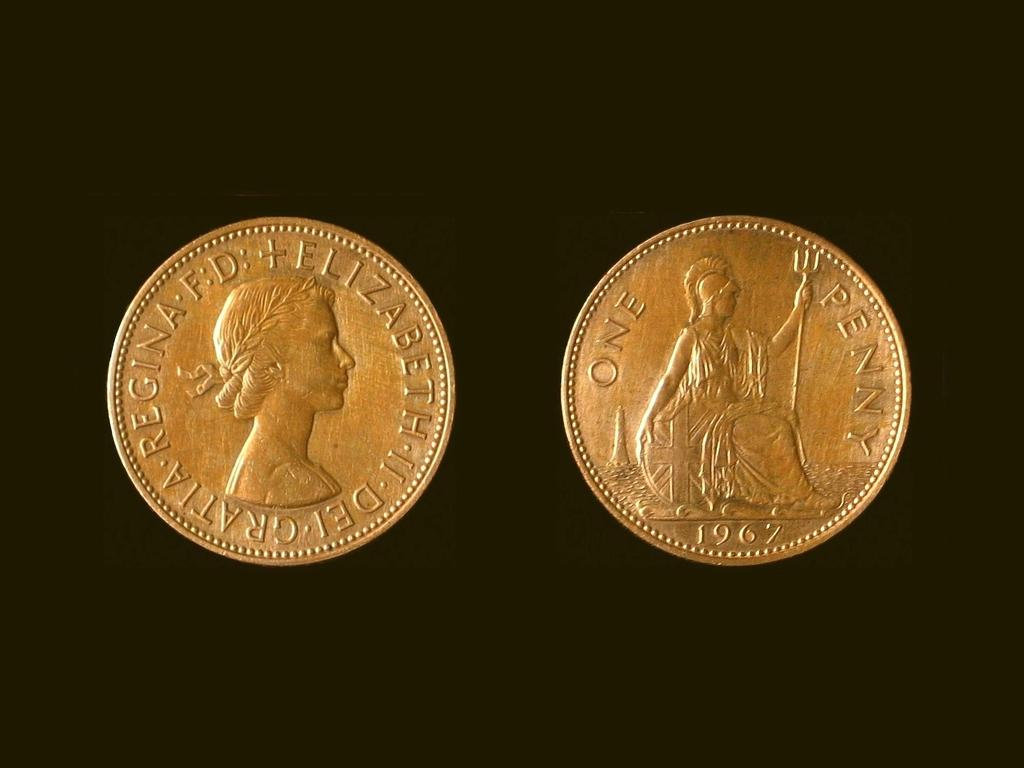What objects are present in the image? There are two coins in the image. What can be observed about the background of the image? The background of the image is dark. How many trains are visible in the image? There are no trains present in the image; it only features two coins. What type of spade is being used by the person in the image? There is no person or spade present in the image. 